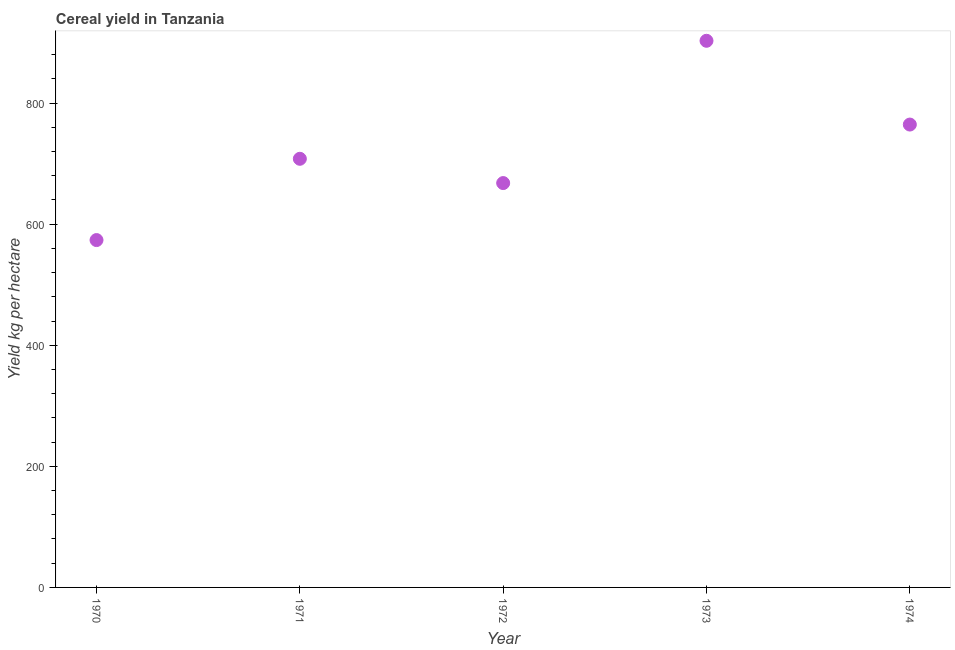What is the cereal yield in 1973?
Provide a short and direct response. 903. Across all years, what is the maximum cereal yield?
Ensure brevity in your answer.  903. Across all years, what is the minimum cereal yield?
Your answer should be very brief. 573.8. What is the sum of the cereal yield?
Provide a succinct answer. 3617.45. What is the difference between the cereal yield in 1972 and 1974?
Your answer should be very brief. -96.65. What is the average cereal yield per year?
Provide a short and direct response. 723.49. What is the median cereal yield?
Make the answer very short. 708.07. Do a majority of the years between 1973 and 1974 (inclusive) have cereal yield greater than 560 kg per hectare?
Offer a terse response. Yes. What is the ratio of the cereal yield in 1970 to that in 1971?
Your answer should be very brief. 0.81. Is the difference between the cereal yield in 1970 and 1973 greater than the difference between any two years?
Your answer should be compact. Yes. What is the difference between the highest and the second highest cereal yield?
Offer a very short reply. 138.38. Is the sum of the cereal yield in 1971 and 1972 greater than the maximum cereal yield across all years?
Provide a short and direct response. Yes. What is the difference between the highest and the lowest cereal yield?
Offer a very short reply. 329.2. How many dotlines are there?
Your answer should be compact. 1. How many years are there in the graph?
Make the answer very short. 5. What is the difference between two consecutive major ticks on the Y-axis?
Provide a short and direct response. 200. Are the values on the major ticks of Y-axis written in scientific E-notation?
Make the answer very short. No. What is the title of the graph?
Offer a very short reply. Cereal yield in Tanzania. What is the label or title of the Y-axis?
Offer a very short reply. Yield kg per hectare. What is the Yield kg per hectare in 1970?
Offer a terse response. 573.8. What is the Yield kg per hectare in 1971?
Keep it short and to the point. 708.07. What is the Yield kg per hectare in 1972?
Your answer should be very brief. 667.97. What is the Yield kg per hectare in 1973?
Make the answer very short. 903. What is the Yield kg per hectare in 1974?
Your answer should be compact. 764.62. What is the difference between the Yield kg per hectare in 1970 and 1971?
Offer a terse response. -134.26. What is the difference between the Yield kg per hectare in 1970 and 1972?
Provide a succinct answer. -94.16. What is the difference between the Yield kg per hectare in 1970 and 1973?
Offer a terse response. -329.19. What is the difference between the Yield kg per hectare in 1970 and 1974?
Provide a succinct answer. -190.81. What is the difference between the Yield kg per hectare in 1971 and 1972?
Provide a short and direct response. 40.1. What is the difference between the Yield kg per hectare in 1971 and 1973?
Provide a short and direct response. -194.93. What is the difference between the Yield kg per hectare in 1971 and 1974?
Your answer should be very brief. -56.55. What is the difference between the Yield kg per hectare in 1972 and 1973?
Ensure brevity in your answer.  -235.03. What is the difference between the Yield kg per hectare in 1972 and 1974?
Provide a short and direct response. -96.65. What is the difference between the Yield kg per hectare in 1973 and 1974?
Your answer should be very brief. 138.38. What is the ratio of the Yield kg per hectare in 1970 to that in 1971?
Offer a terse response. 0.81. What is the ratio of the Yield kg per hectare in 1970 to that in 1972?
Ensure brevity in your answer.  0.86. What is the ratio of the Yield kg per hectare in 1970 to that in 1973?
Ensure brevity in your answer.  0.64. What is the ratio of the Yield kg per hectare in 1970 to that in 1974?
Ensure brevity in your answer.  0.75. What is the ratio of the Yield kg per hectare in 1971 to that in 1972?
Ensure brevity in your answer.  1.06. What is the ratio of the Yield kg per hectare in 1971 to that in 1973?
Offer a very short reply. 0.78. What is the ratio of the Yield kg per hectare in 1971 to that in 1974?
Provide a succinct answer. 0.93. What is the ratio of the Yield kg per hectare in 1972 to that in 1973?
Provide a succinct answer. 0.74. What is the ratio of the Yield kg per hectare in 1972 to that in 1974?
Offer a terse response. 0.87. What is the ratio of the Yield kg per hectare in 1973 to that in 1974?
Your answer should be very brief. 1.18. 